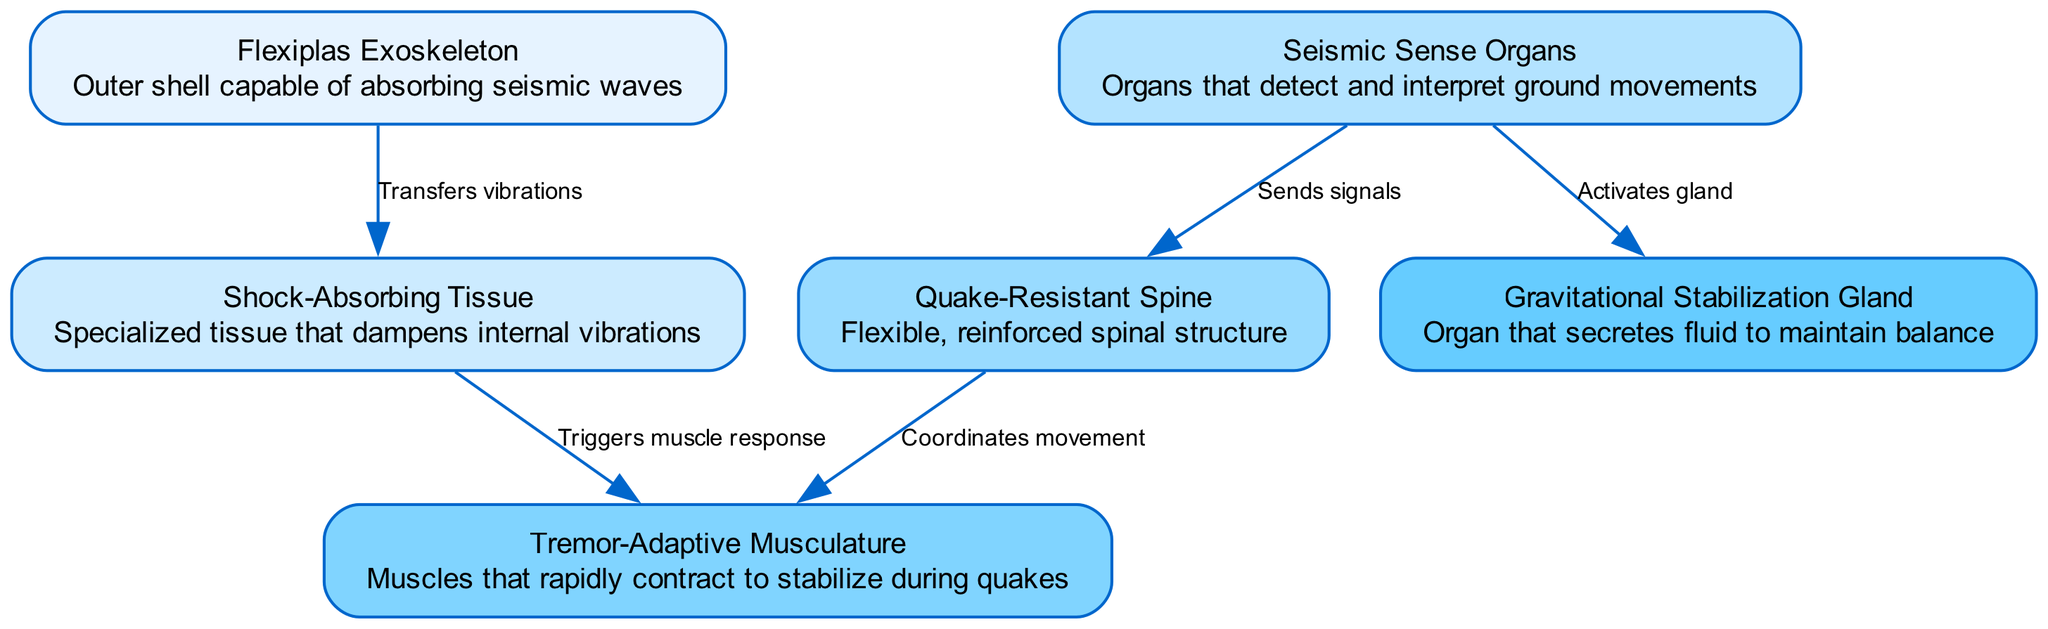What is the primary function of the Flexiplas Exoskeleton? The Flexiplas Exoskeleton is described as an "Outer shell capable of absorbing seismic waves," indicating its role as a protective layer against seismic activity.
Answer: Absorbing seismic waves How many internal structures are highlighted in the diagram? The diagram lists six nodes that identify unique internal structures of the alien organism, counting each labeled feature helps determine the total.
Answer: Six Which organ is responsible for detecting ground movements? The Seismic Sense Organs, as labeled in the diagram, specifically state that they "detect and interpret ground movements," identifying them as the sensory structures for seismic activity.
Answer: Seismic Sense Organs What is the relationship between Shock-Absorbing Tissue and Tremor-Adaptive Musculature? The diagram shows that the Shock-Absorbing Tissue "Triggers muscle response," which directly links it to the Tremor-Adaptive Musculature, as vibrations are dampened before the muscles react.
Answer: Triggers muscle response What mechanism connects Seismic Sense Organs to Gravitational Stabilization Gland? The Seismic Sense Organs "Activates gland," meaning that these sensory organs initiate a response in the Gravitational Stabilization Gland to help stabilize the organism's position during seismic events.
Answer: Activates gland How does the Quake-Resistant Spine support the Tremor-Adaptive Musculature? According to the diagram's connections, the Quake-Resistant Spine "Coordinates movement," allowing it to work in conjunction with the Tremor-Adaptive Musculature, which stabilizes during quakes by rapidly contracting.
Answer: Coordinates movement 